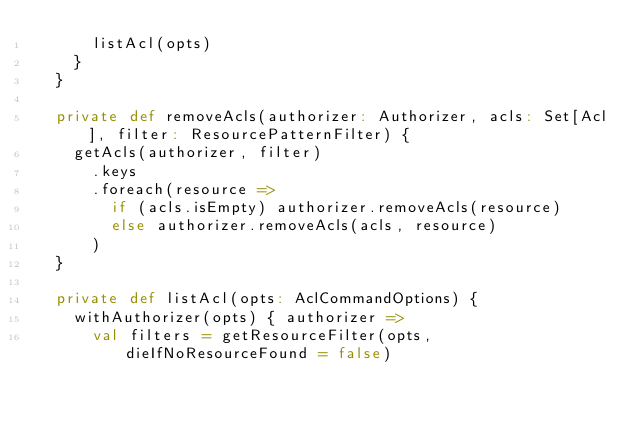Convert code to text. <code><loc_0><loc_0><loc_500><loc_500><_Scala_>      listAcl(opts)
    }
  }

  private def removeAcls(authorizer: Authorizer, acls: Set[Acl], filter: ResourcePatternFilter) {
    getAcls(authorizer, filter)
      .keys
      .foreach(resource =>
        if (acls.isEmpty) authorizer.removeAcls(resource)
        else authorizer.removeAcls(acls, resource)
      )
  }

  private def listAcl(opts: AclCommandOptions) {
    withAuthorizer(opts) { authorizer =>
      val filters = getResourceFilter(opts, dieIfNoResourceFound = false)
</code> 